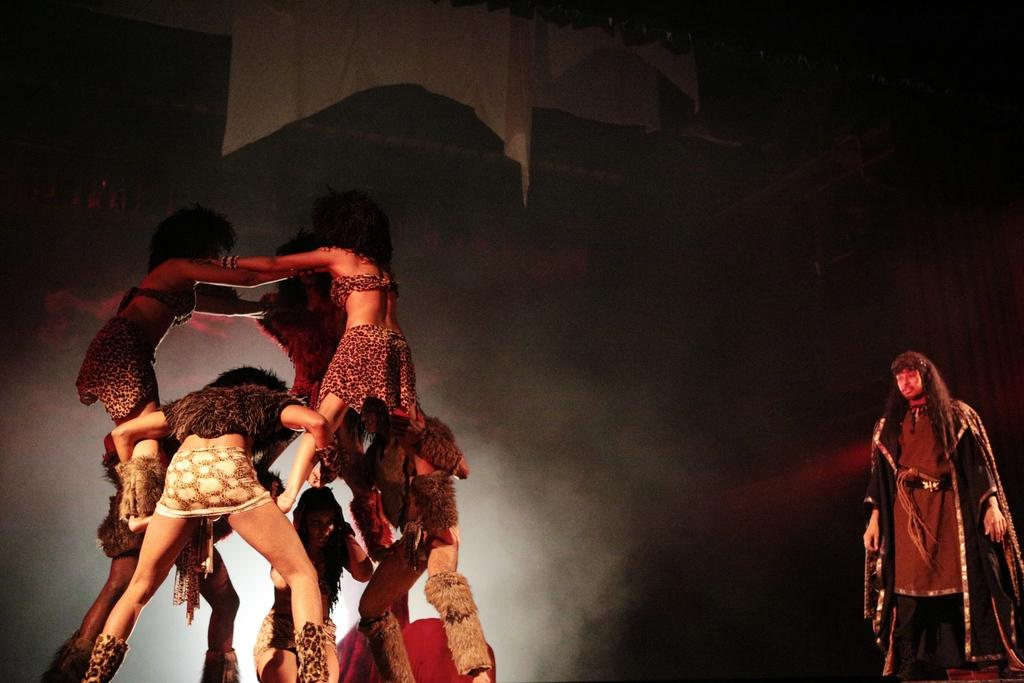Who or what can be seen in the image? There are people in the image. What are the people doing in the image? Some people are standing on others. What else is present in the image besides the people? There are clothes in the image. What can be observed about the background of the image? The background of the image is dark. What type of wire is being used by the grandmother in the image? There is no grandmother or wire present in the image. What time does the clock show in the image? There is no clock present in the image. 